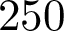<formula> <loc_0><loc_0><loc_500><loc_500>2 5 0</formula> 